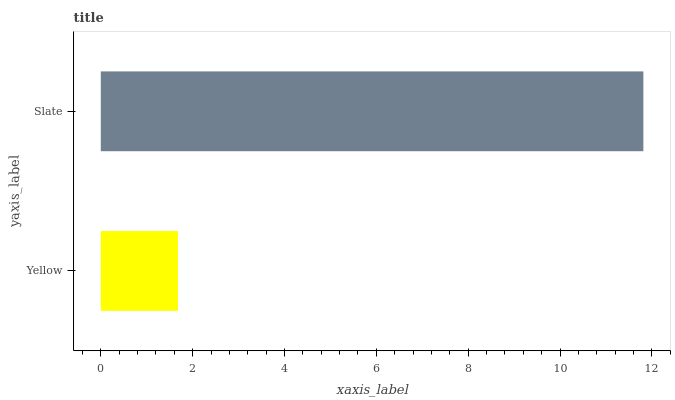Is Yellow the minimum?
Answer yes or no. Yes. Is Slate the maximum?
Answer yes or no. Yes. Is Slate the minimum?
Answer yes or no. No. Is Slate greater than Yellow?
Answer yes or no. Yes. Is Yellow less than Slate?
Answer yes or no. Yes. Is Yellow greater than Slate?
Answer yes or no. No. Is Slate less than Yellow?
Answer yes or no. No. Is Slate the high median?
Answer yes or no. Yes. Is Yellow the low median?
Answer yes or no. Yes. Is Yellow the high median?
Answer yes or no. No. Is Slate the low median?
Answer yes or no. No. 